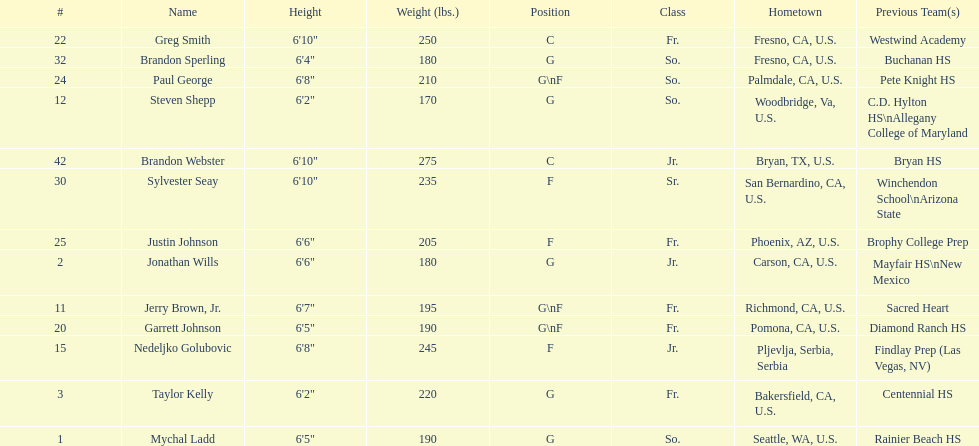Who is the exclusive participant not from the u.s.? Nedeljko Golubovic. Parse the table in full. {'header': ['#', 'Name', 'Height', 'Weight (lbs.)', 'Position', 'Class', 'Hometown', 'Previous Team(s)'], 'rows': [['22', 'Greg Smith', '6\'10"', '250', 'C', 'Fr.', 'Fresno, CA, U.S.', 'Westwind Academy'], ['32', 'Brandon Sperling', '6\'4"', '180', 'G', 'So.', 'Fresno, CA, U.S.', 'Buchanan HS'], ['24', 'Paul George', '6\'8"', '210', 'G\\nF', 'So.', 'Palmdale, CA, U.S.', 'Pete Knight HS'], ['12', 'Steven Shepp', '6\'2"', '170', 'G', 'So.', 'Woodbridge, Va, U.S.', 'C.D. Hylton HS\\nAllegany College of Maryland'], ['42', 'Brandon Webster', '6\'10"', '275', 'C', 'Jr.', 'Bryan, TX, U.S.', 'Bryan HS'], ['30', 'Sylvester Seay', '6\'10"', '235', 'F', 'Sr.', 'San Bernardino, CA, U.S.', 'Winchendon School\\nArizona State'], ['25', 'Justin Johnson', '6\'6"', '205', 'F', 'Fr.', 'Phoenix, AZ, U.S.', 'Brophy College Prep'], ['2', 'Jonathan Wills', '6\'6"', '180', 'G', 'Jr.', 'Carson, CA, U.S.', 'Mayfair HS\\nNew Mexico'], ['11', 'Jerry Brown, Jr.', '6\'7"', '195', 'G\\nF', 'Fr.', 'Richmond, CA, U.S.', 'Sacred Heart'], ['20', 'Garrett Johnson', '6\'5"', '190', 'G\\nF', 'Fr.', 'Pomona, CA, U.S.', 'Diamond Ranch HS'], ['15', 'Nedeljko Golubovic', '6\'8"', '245', 'F', 'Jr.', 'Pljevlja, Serbia, Serbia', 'Findlay Prep (Las Vegas, NV)'], ['3', 'Taylor Kelly', '6\'2"', '220', 'G', 'Fr.', 'Bakersfield, CA, U.S.', 'Centennial HS'], ['1', 'Mychal Ladd', '6\'5"', '190', 'G', 'So.', 'Seattle, WA, U.S.', 'Rainier Beach HS']]} 